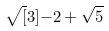<formula> <loc_0><loc_0><loc_500><loc_500>\sqrt { [ } 3 ] { - 2 + \sqrt { 5 } }</formula> 